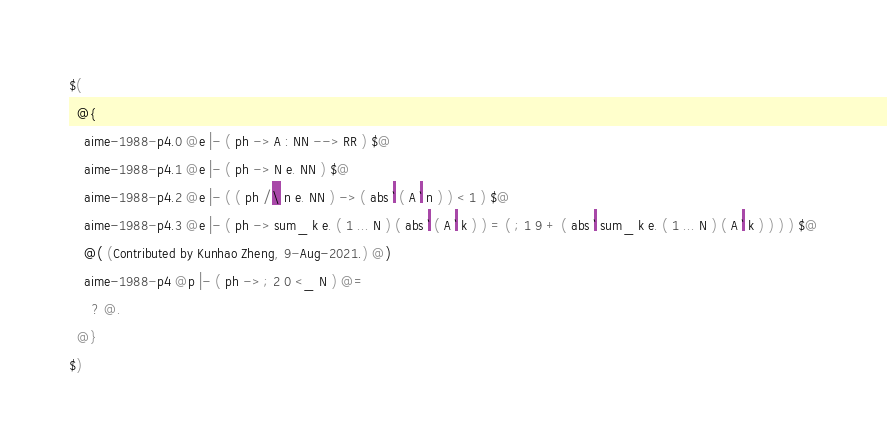Convert code to text. <code><loc_0><loc_0><loc_500><loc_500><_ObjectiveC_>$(
  @{
    aime-1988-p4.0 @e |- ( ph -> A : NN --> RR ) $@
    aime-1988-p4.1 @e |- ( ph -> N e. NN ) $@
    aime-1988-p4.2 @e |- ( ( ph /\ n e. NN ) -> ( abs ` ( A ` n ) ) < 1 ) $@
    aime-1988-p4.3 @e |- ( ph -> sum_ k e. ( 1 ... N ) ( abs ` ( A ` k ) ) = ( ; 1 9 + ( abs ` sum_ k e. ( 1 ... N ) ( A ` k ) ) ) ) $@
    @( (Contributed by Kunhao Zheng, 9-Aug-2021.) @)
    aime-1988-p4 @p |- ( ph -> ; 2 0 <_ N ) @=
      ? @.
  @}
$)
</code> 